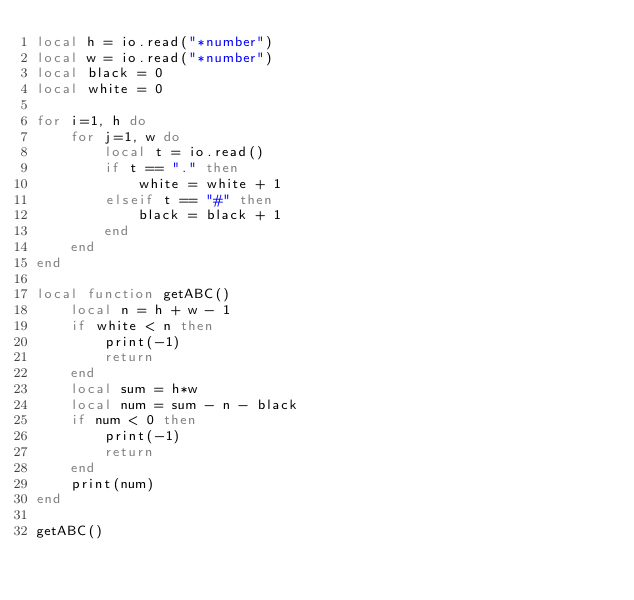Convert code to text. <code><loc_0><loc_0><loc_500><loc_500><_Lua_>local h = io.read("*number")
local w = io.read("*number")
local black = 0
local white = 0

for i=1, h do
	for j=1, w do
		local t = io.read()
		if t == "." then
			white = white + 1
		elseif t == "#" then
			black = black + 1
		end
	end
end

local function getABC()
	local n = h + w - 1
	if white < n then
		print(-1)
		return
	end
	local sum = h*w
	local num = sum - n - black
	if num < 0 then
		print(-1)
		return
	end
	print(num)
end

getABC()</code> 